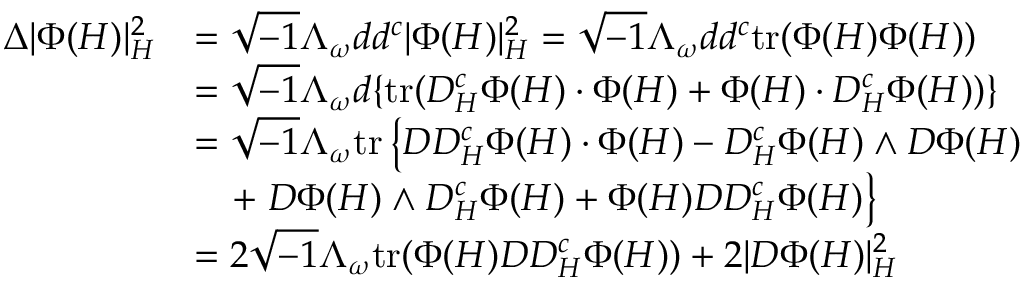Convert formula to latex. <formula><loc_0><loc_0><loc_500><loc_500>\begin{array} { r l } { \Delta | \Phi ( H ) | _ { H } ^ { 2 } } & { = \sqrt { - 1 } \Lambda _ { \omega } d d ^ { c } | \Phi ( H ) | _ { H } ^ { 2 } = \sqrt { - 1 } \Lambda _ { \omega } d d ^ { c } t r ( \Phi ( H ) \Phi ( H ) ) } \\ & { = \sqrt { - 1 } \Lambda _ { \omega } d \{ t r ( D _ { H } ^ { c } \Phi ( H ) \cdot \Phi ( H ) + \Phi ( H ) \cdot D _ { H } ^ { c } \Phi ( H ) ) \} } \\ & { = \sqrt { - 1 } \Lambda _ { \omega } t r \left \{ D D _ { H } ^ { c } \Phi ( H ) \cdot \Phi ( H ) - D _ { H } ^ { c } \Phi ( H ) \wedge D \Phi ( H ) } \\ & { \quad + D \Phi ( H ) \wedge D _ { H } ^ { c } \Phi ( H ) + \Phi ( H ) D D _ { H } ^ { c } \Phi ( H ) \right \} } \\ & { = 2 \sqrt { - 1 } \Lambda _ { \omega } t r ( \Phi ( H ) D D _ { H } ^ { c } \Phi ( H ) ) + 2 | D \Phi ( H ) | _ { H } ^ { 2 } } \end{array}</formula> 